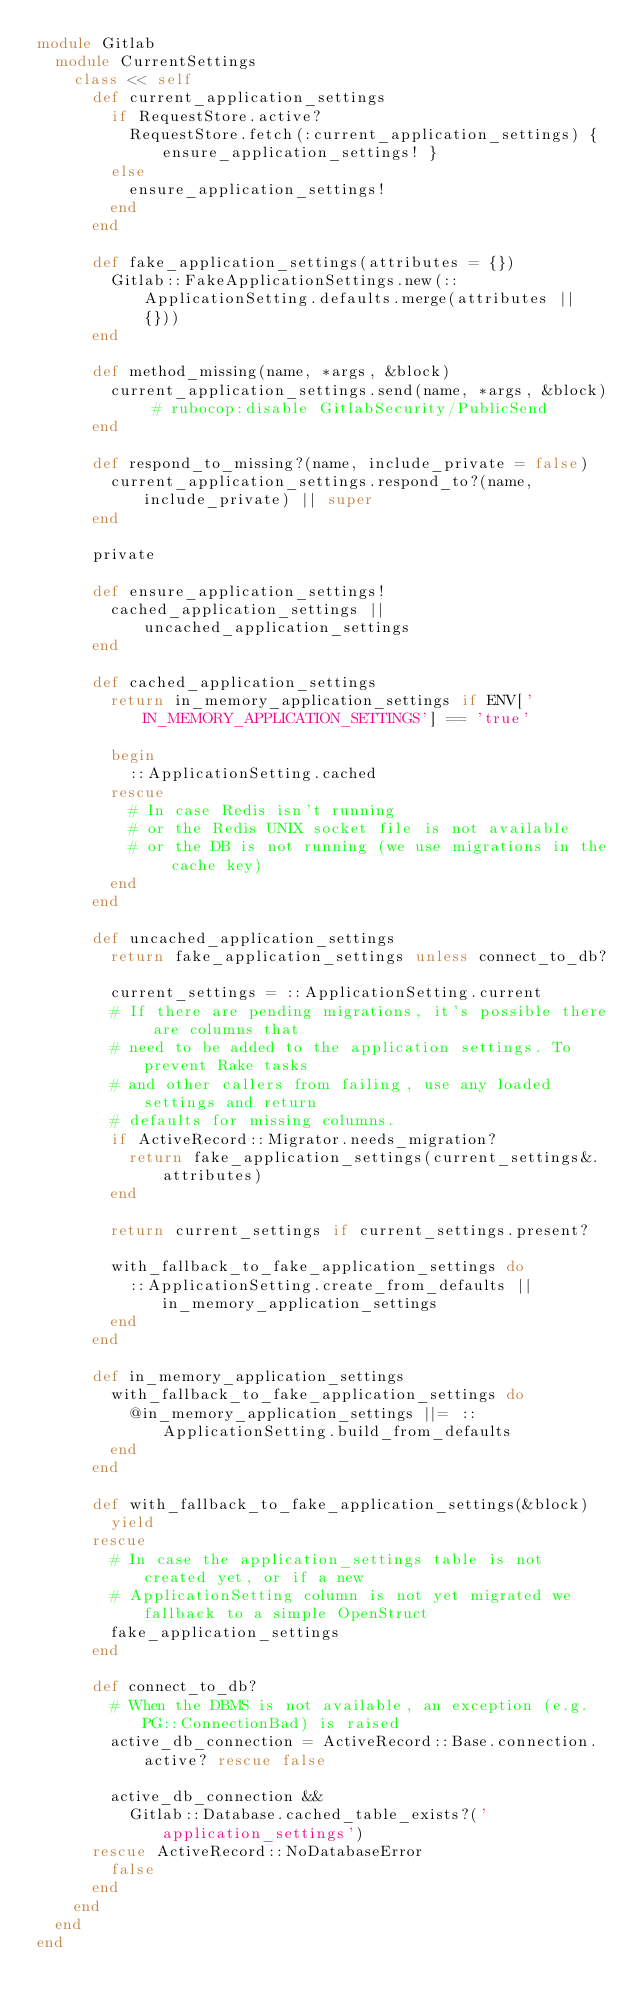Convert code to text. <code><loc_0><loc_0><loc_500><loc_500><_Ruby_>module Gitlab
  module CurrentSettings
    class << self
      def current_application_settings
        if RequestStore.active?
          RequestStore.fetch(:current_application_settings) { ensure_application_settings! }
        else
          ensure_application_settings!
        end
      end

      def fake_application_settings(attributes = {})
        Gitlab::FakeApplicationSettings.new(::ApplicationSetting.defaults.merge(attributes || {}))
      end

      def method_missing(name, *args, &block)
        current_application_settings.send(name, *args, &block) # rubocop:disable GitlabSecurity/PublicSend
      end

      def respond_to_missing?(name, include_private = false)
        current_application_settings.respond_to?(name, include_private) || super
      end

      private

      def ensure_application_settings!
        cached_application_settings || uncached_application_settings
      end

      def cached_application_settings
        return in_memory_application_settings if ENV['IN_MEMORY_APPLICATION_SETTINGS'] == 'true'

        begin
          ::ApplicationSetting.cached
        rescue
          # In case Redis isn't running
          # or the Redis UNIX socket file is not available
          # or the DB is not running (we use migrations in the cache key)
        end
      end

      def uncached_application_settings
        return fake_application_settings unless connect_to_db?

        current_settings = ::ApplicationSetting.current
        # If there are pending migrations, it's possible there are columns that
        # need to be added to the application settings. To prevent Rake tasks
        # and other callers from failing, use any loaded settings and return
        # defaults for missing columns.
        if ActiveRecord::Migrator.needs_migration?
          return fake_application_settings(current_settings&.attributes)
        end

        return current_settings if current_settings.present?

        with_fallback_to_fake_application_settings do
          ::ApplicationSetting.create_from_defaults || in_memory_application_settings
        end
      end

      def in_memory_application_settings
        with_fallback_to_fake_application_settings do
          @in_memory_application_settings ||= ::ApplicationSetting.build_from_defaults
        end
      end

      def with_fallback_to_fake_application_settings(&block)
        yield
      rescue
        # In case the application_settings table is not created yet, or if a new
        # ApplicationSetting column is not yet migrated we fallback to a simple OpenStruct
        fake_application_settings
      end

      def connect_to_db?
        # When the DBMS is not available, an exception (e.g. PG::ConnectionBad) is raised
        active_db_connection = ActiveRecord::Base.connection.active? rescue false

        active_db_connection &&
          Gitlab::Database.cached_table_exists?('application_settings')
      rescue ActiveRecord::NoDatabaseError
        false
      end
    end
  end
end
</code> 